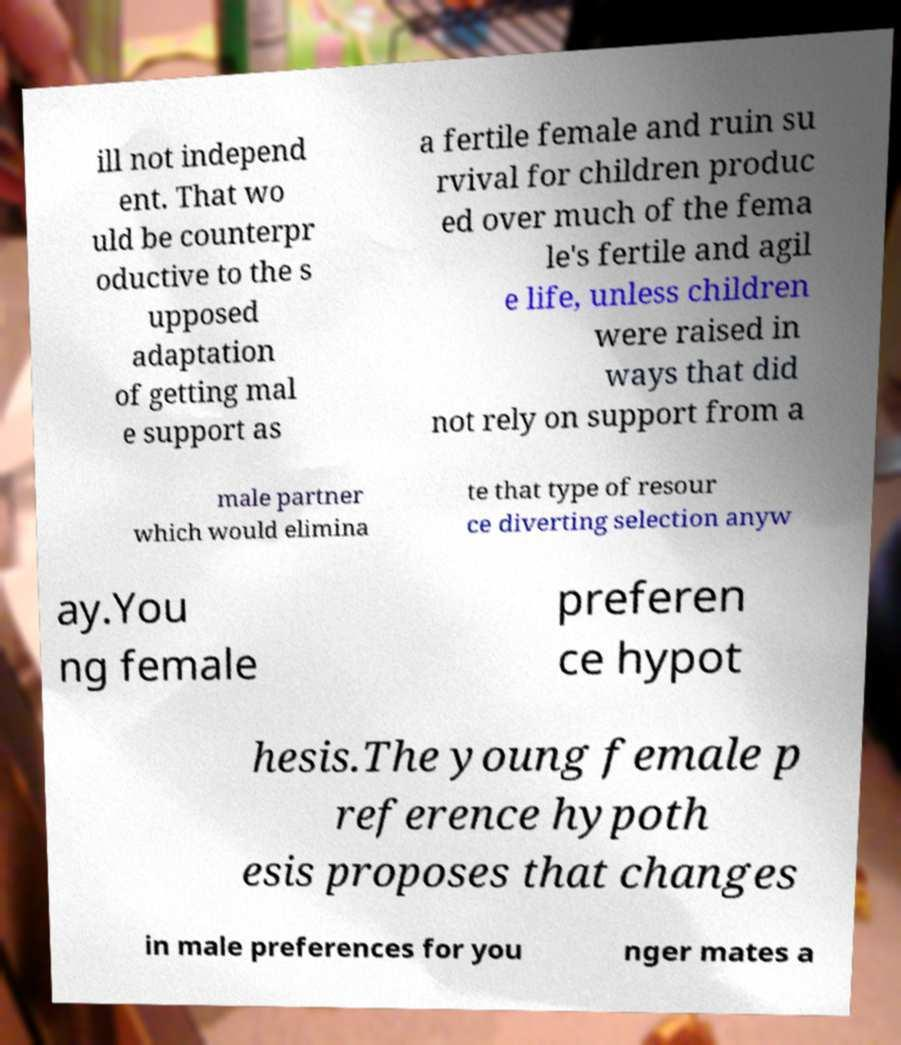Please identify and transcribe the text found in this image. ill not independ ent. That wo uld be counterpr oductive to the s upposed adaptation of getting mal e support as a fertile female and ruin su rvival for children produc ed over much of the fema le's fertile and agil e life, unless children were raised in ways that did not rely on support from a male partner which would elimina te that type of resour ce diverting selection anyw ay.You ng female preferen ce hypot hesis.The young female p reference hypoth esis proposes that changes in male preferences for you nger mates a 